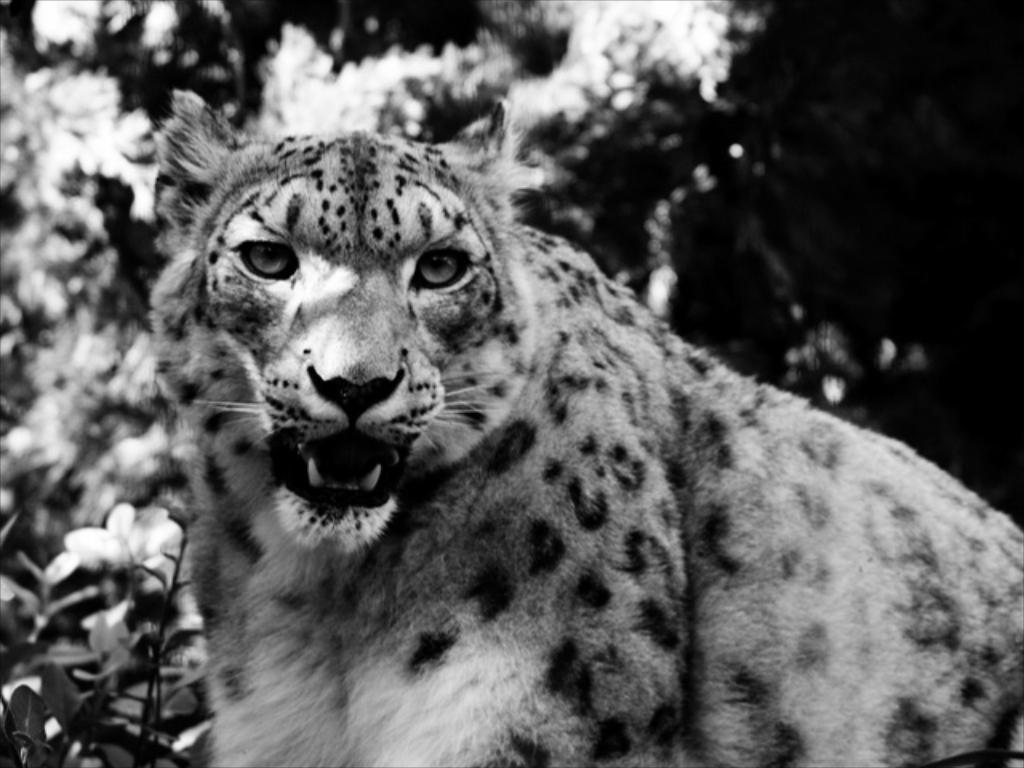What type of living organism is present in the image? There is an animal in the image. What type of plant life is visible in the image? There are flowers and leaves in the image. Where is the toothbrush located in the image? There is no toothbrush present in the image. What type of base is supporting the animal in the image? There is no base present in the image, and the animal's support is not mentioned in the provided facts. 